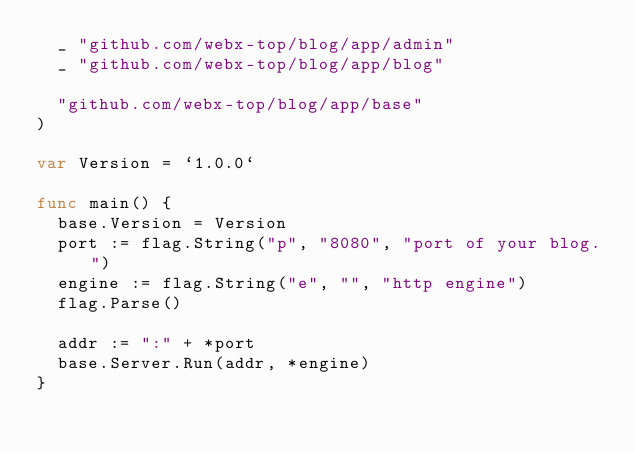<code> <loc_0><loc_0><loc_500><loc_500><_Go_>	_ "github.com/webx-top/blog/app/admin"
	_ "github.com/webx-top/blog/app/blog"

	"github.com/webx-top/blog/app/base"
)

var Version = `1.0.0`

func main() {
	base.Version = Version
	port := flag.String("p", "8080", "port of your blog.")
	engine := flag.String("e", "", "http engine")
	flag.Parse()

	addr := ":" + *port
	base.Server.Run(addr, *engine)
}
</code> 